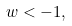<formula> <loc_0><loc_0><loc_500><loc_500>w < - 1 ,</formula> 